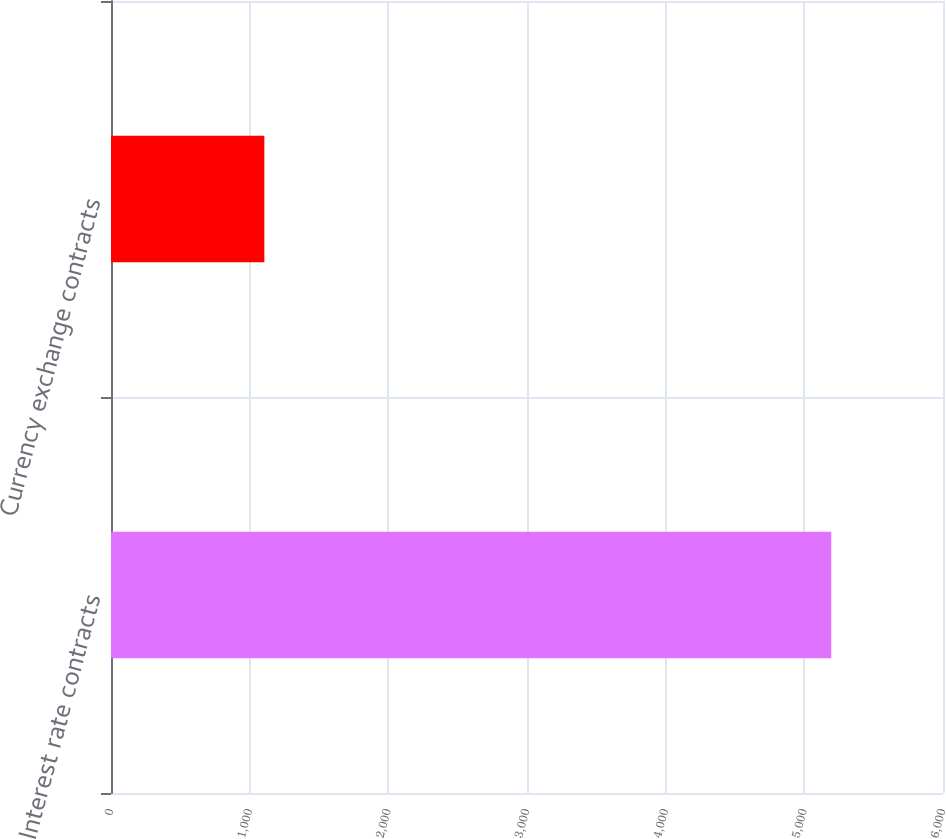Convert chart to OTSL. <chart><loc_0><loc_0><loc_500><loc_500><bar_chart><fcel>Interest rate contracts<fcel>Currency exchange contracts<nl><fcel>5194<fcel>1106<nl></chart> 